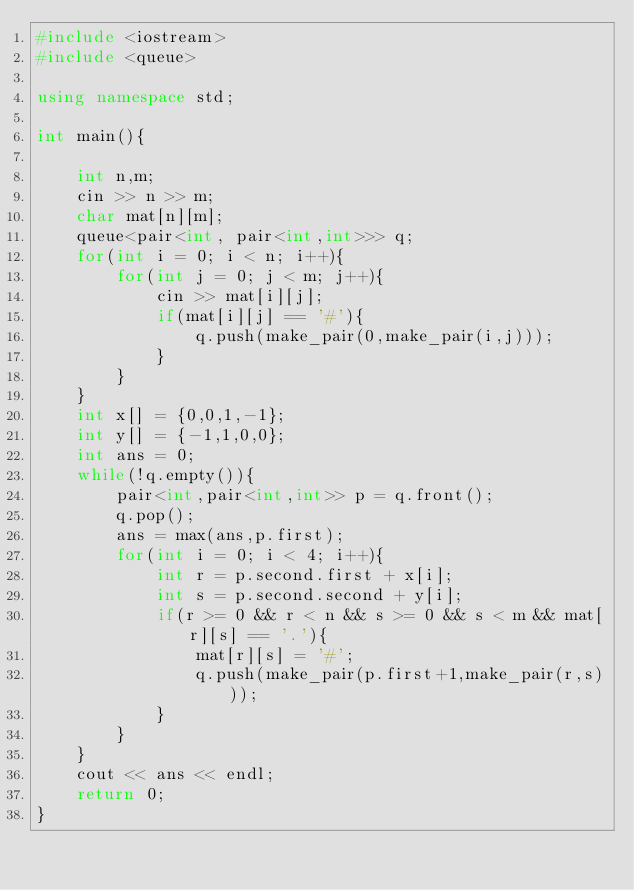<code> <loc_0><loc_0><loc_500><loc_500><_C++_>#include <iostream>
#include <queue>

using namespace std;

int main(){

    int n,m;
    cin >> n >> m;
    char mat[n][m];
    queue<pair<int, pair<int,int>>> q;
    for(int i = 0; i < n; i++){
        for(int j = 0; j < m; j++){
            cin >> mat[i][j];
            if(mat[i][j] == '#'){
                q.push(make_pair(0,make_pair(i,j)));
            }
        }
    }
    int x[] = {0,0,1,-1};
    int y[] = {-1,1,0,0};
    int ans = 0;
    while(!q.empty()){
        pair<int,pair<int,int>> p = q.front();
        q.pop();
        ans = max(ans,p.first);
        for(int i = 0; i < 4; i++){
            int r = p.second.first + x[i];
            int s = p.second.second + y[i];
            if(r >= 0 && r < n && s >= 0 && s < m && mat[r][s] == '.'){
                mat[r][s] = '#';
                q.push(make_pair(p.first+1,make_pair(r,s)));
            }
        }
    }
    cout << ans << endl;
    return 0;
}
</code> 